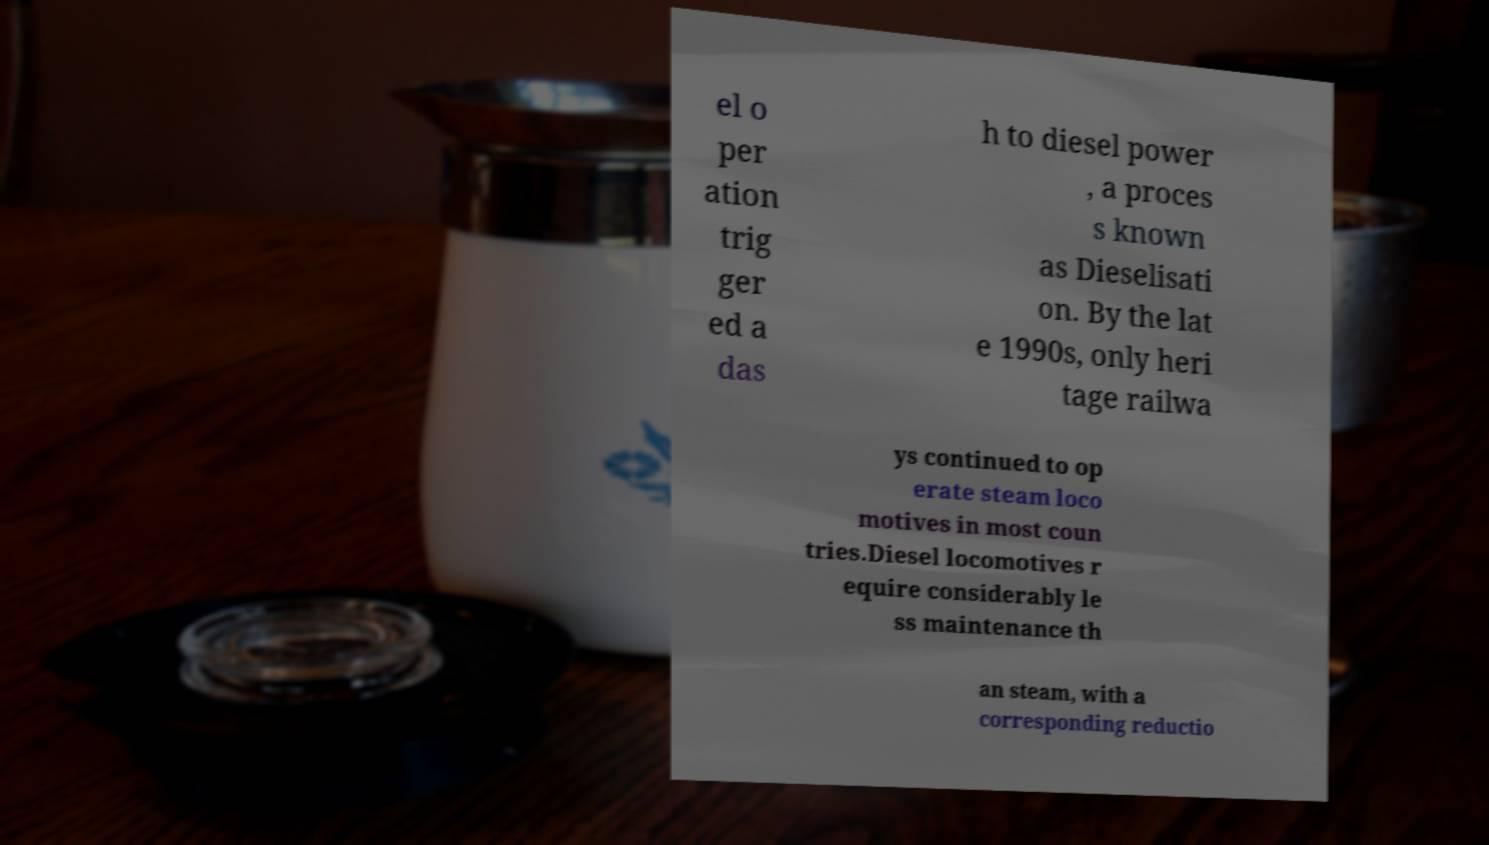Could you assist in decoding the text presented in this image and type it out clearly? el o per ation trig ger ed a das h to diesel power , a proces s known as Dieselisati on. By the lat e 1990s, only heri tage railwa ys continued to op erate steam loco motives in most coun tries.Diesel locomotives r equire considerably le ss maintenance th an steam, with a corresponding reductio 